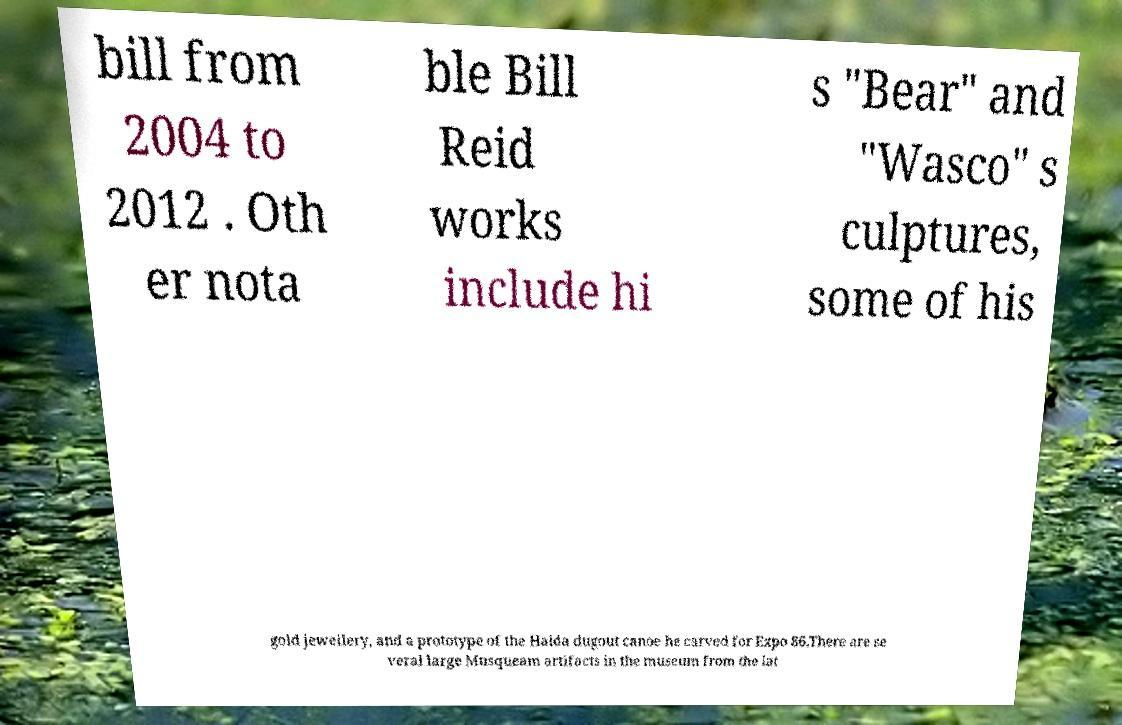Please read and relay the text visible in this image. What does it say? bill from 2004 to 2012 . Oth er nota ble Bill Reid works include hi s "Bear" and "Wasco" s culptures, some of his gold jewellery, and a prototype of the Haida dugout canoe he carved for Expo 86.There are se veral large Musqueam artifacts in the museum from the lat 